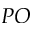<formula> <loc_0><loc_0><loc_500><loc_500>P O</formula> 